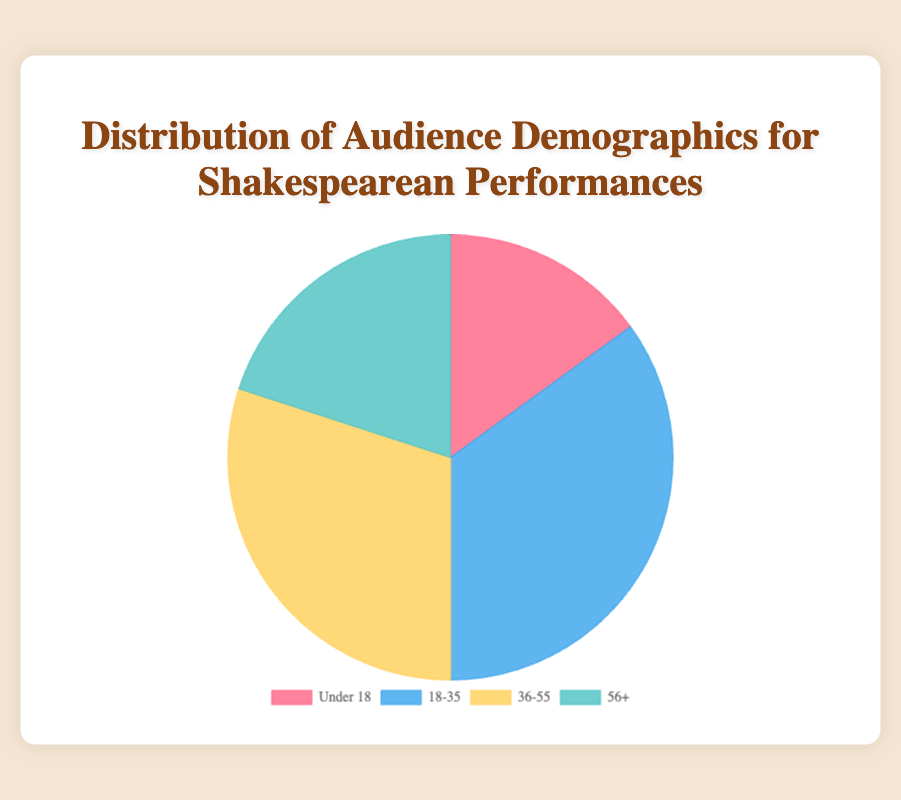What percentage of the audience is aged 36-55? This value can be found directly in the chart, which shows the percentage distribution of each age group.
Answer: 30% Which age group has the highest percentage of the audience? Compare the percentages of all age groups displayed in the chart. The age group with the highest percentage is the one with the largest sector in the pie chart.
Answer: 18-35 What is the combined percentage of the audience aged under 18 and 56+? Add the percentages of the Under 18 group (15%) and the 56+ group (20%). 15% + 20% = 35%
Answer: 35% Which age group has the lowest percentage of the audience? Compare the percentages of all age groups in the chart and identify the smallest value.
Answer: Under 18 How much larger is the 18-35 age group compared to the 56+ age group? Subtract the percentage of the 56+ age group from the percentage of the 18-35 age group. 35% - 20% = 15%
Answer: 15% What is the difference in percentage between the audience aged 18-35 and 36-55? Subtract the percentage of the 36-55 age group from the percentage of the 18-35 age group. 35% - 30% = 5%
Answer: 5% What is the total percentage of the audience aged 18-35 and 36-55? Add the percentages of the 18-35 group (35%) and the 36-55 group (30%). 35% + 30% = 65%
Answer: 65% Which color represents the Under 18 age group? Visual inspection of the chart shows that the Under 18 section is marked in red.
Answer: red 